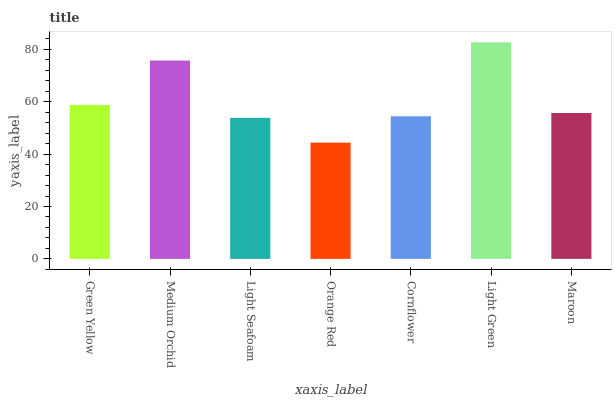Is Medium Orchid the minimum?
Answer yes or no. No. Is Medium Orchid the maximum?
Answer yes or no. No. Is Medium Orchid greater than Green Yellow?
Answer yes or no. Yes. Is Green Yellow less than Medium Orchid?
Answer yes or no. Yes. Is Green Yellow greater than Medium Orchid?
Answer yes or no. No. Is Medium Orchid less than Green Yellow?
Answer yes or no. No. Is Maroon the high median?
Answer yes or no. Yes. Is Maroon the low median?
Answer yes or no. Yes. Is Orange Red the high median?
Answer yes or no. No. Is Light Green the low median?
Answer yes or no. No. 